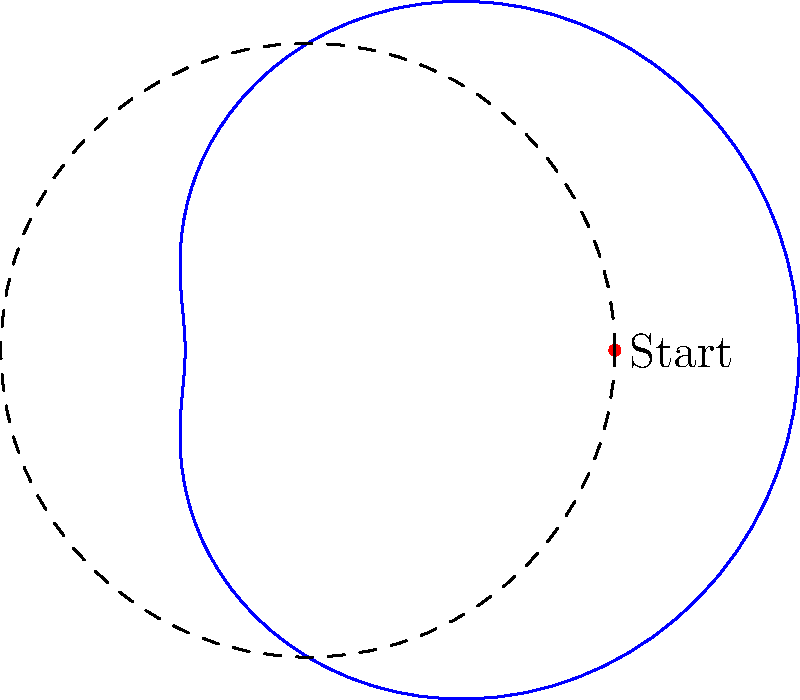As a dog walker, you're playing frisbee with a client's dog in the park. The trajectory of the frisbee can be described by the polar equation $r = 5 + 3\cos(\theta)$, where $r$ is in meters. What is the maximum distance, in meters, that the frisbee travels from the throwing point? To find the maximum distance the frisbee travels, we need to follow these steps:

1) The general form of the equation is $r = a + b\cos(\theta)$, where $a = 5$ and $b = 3$.

2) The maximum distance occurs when $\cos(\theta) = 1$, which happens when $\theta = 0$ or $2\pi$.

3) At this point, the maximum $r$ value is:

   $r_{max} = a + b = 5 + 3 = 8$

4) The minimum distance occurs when $\cos(\theta) = -1$, which happens when $\theta = \pi$.

5) At this point, the minimum $r$ value is:

   $r_{min} = a - b = 5 - 3 = 2$

6) The maximum distance from the throwing point is the difference between $r_{max}$ and $r_{min}$:

   $d_{max} = r_{max} - r_{min} = 8 - 2 = 6$

Therefore, the maximum distance the frisbee travels from the throwing point is 6 meters.
Answer: 6 meters 